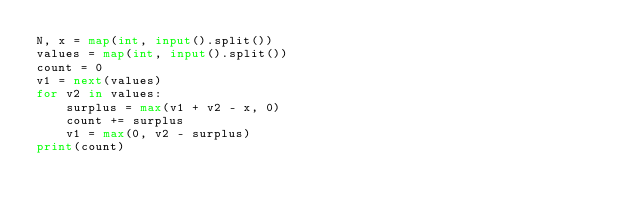Convert code to text. <code><loc_0><loc_0><loc_500><loc_500><_Python_>N, x = map(int, input().split())
values = map(int, input().split())
count = 0
v1 = next(values)
for v2 in values:
    surplus = max(v1 + v2 - x, 0)
    count += surplus
    v1 = max(0, v2 - surplus)
print(count)</code> 